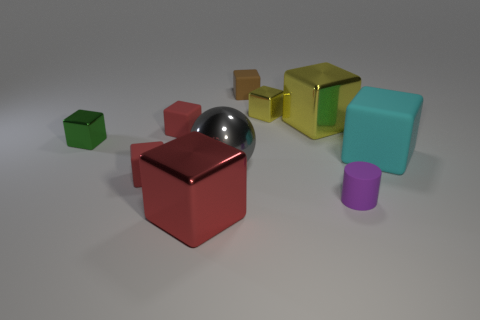Subtract all tiny green cubes. How many cubes are left? 7 Subtract all green blocks. How many blocks are left? 7 Subtract 2 cubes. How many cubes are left? 6 Subtract all red cubes. Subtract all cyan cylinders. How many cubes are left? 5 Subtract all brown spheres. How many cyan blocks are left? 1 Add 5 brown objects. How many brown objects are left? 6 Add 7 small purple rubber cylinders. How many small purple rubber cylinders exist? 8 Subtract 2 red cubes. How many objects are left? 8 Subtract all spheres. How many objects are left? 9 Subtract all cyan metallic cubes. Subtract all red blocks. How many objects are left? 7 